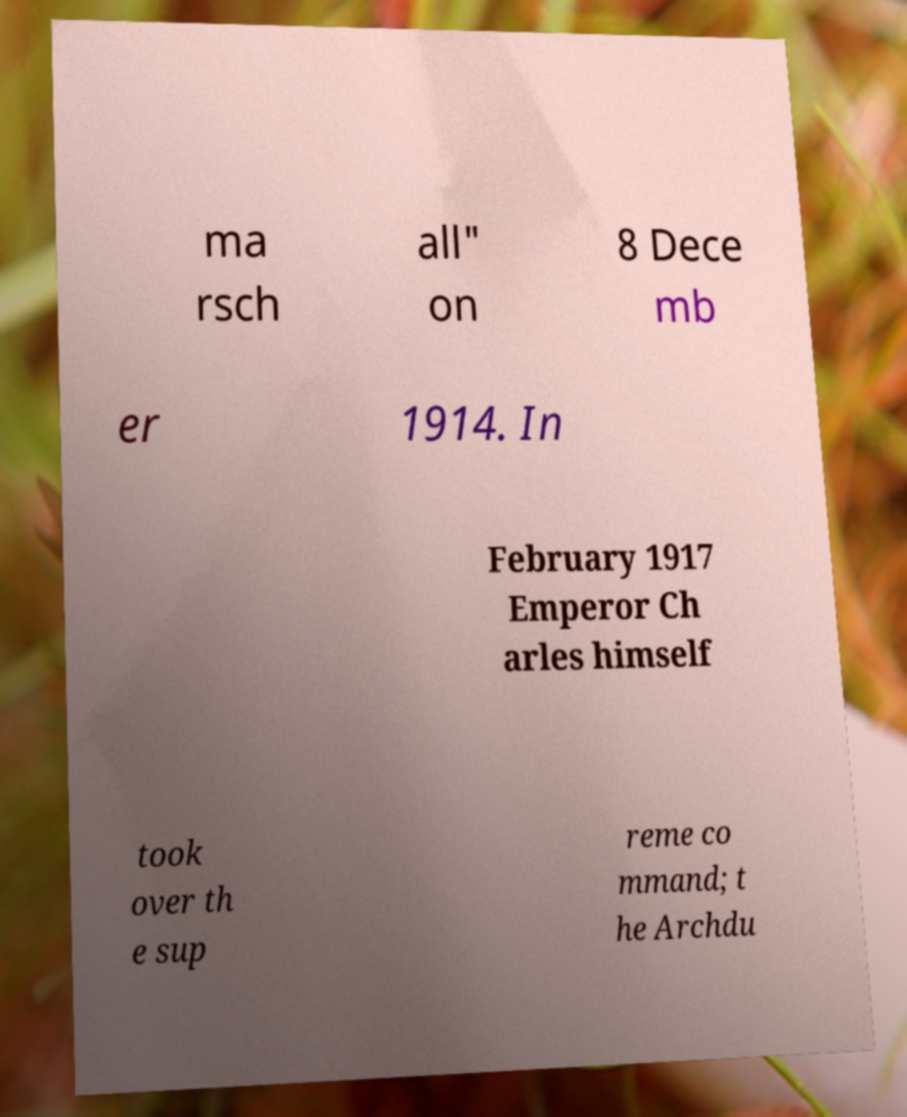Could you extract and type out the text from this image? ma rsch all" on 8 Dece mb er 1914. In February 1917 Emperor Ch arles himself took over th e sup reme co mmand; t he Archdu 